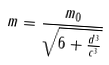<formula> <loc_0><loc_0><loc_500><loc_500>m = \frac { m _ { 0 } } { \sqrt { 6 + \frac { d ^ { 3 } } { c ^ { 3 } } } }</formula> 